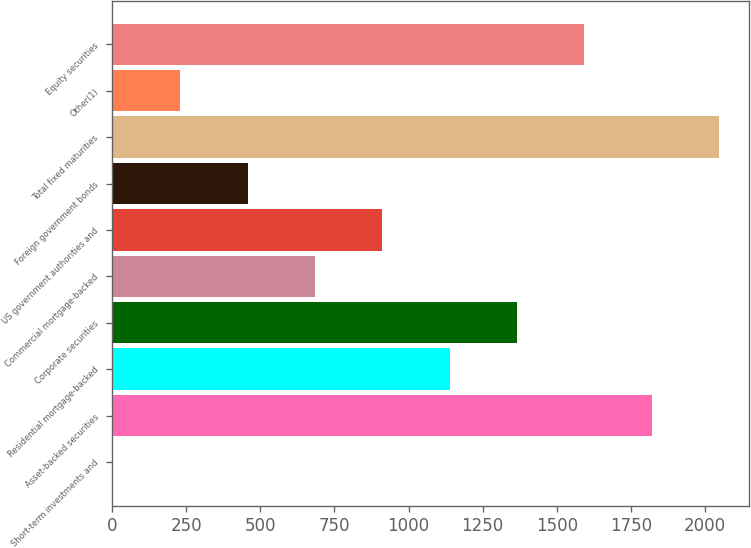Convert chart to OTSL. <chart><loc_0><loc_0><loc_500><loc_500><bar_chart><fcel>Short-term investments and<fcel>Asset-backed securities<fcel>Residential mortgage-backed<fcel>Corporate securities<fcel>Commercial mortgage-backed<fcel>US government authorities and<fcel>Foreign government bonds<fcel>Total fixed maturities<fcel>Other(1)<fcel>Equity securities<nl><fcel>3<fcel>1819.8<fcel>1138.5<fcel>1365.6<fcel>684.3<fcel>911.4<fcel>457.2<fcel>2046.9<fcel>230.1<fcel>1592.7<nl></chart> 